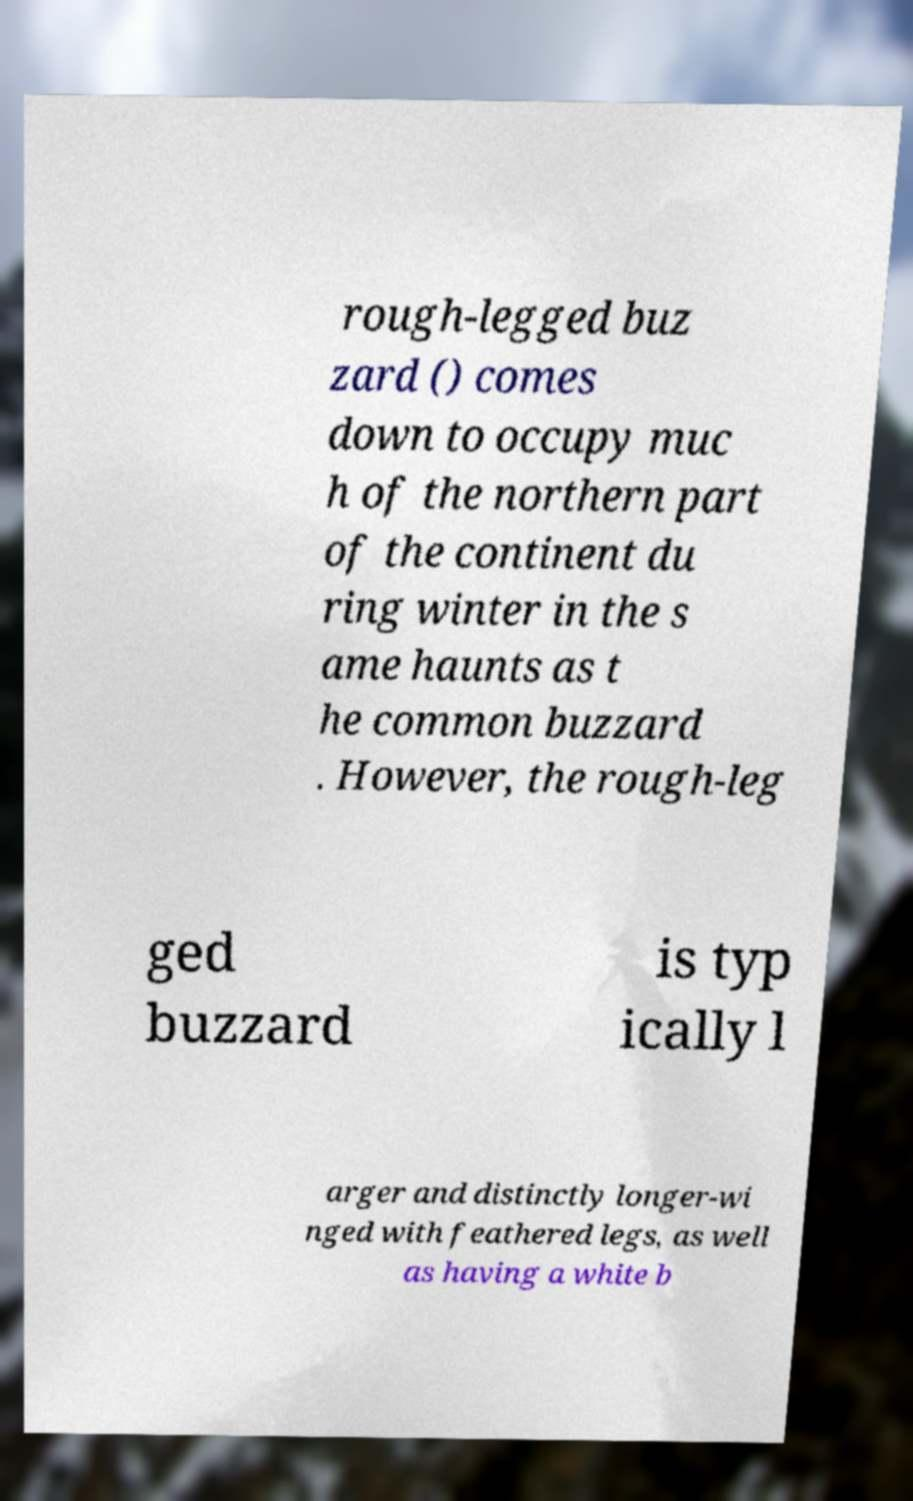Could you assist in decoding the text presented in this image and type it out clearly? rough-legged buz zard () comes down to occupy muc h of the northern part of the continent du ring winter in the s ame haunts as t he common buzzard . However, the rough-leg ged buzzard is typ ically l arger and distinctly longer-wi nged with feathered legs, as well as having a white b 